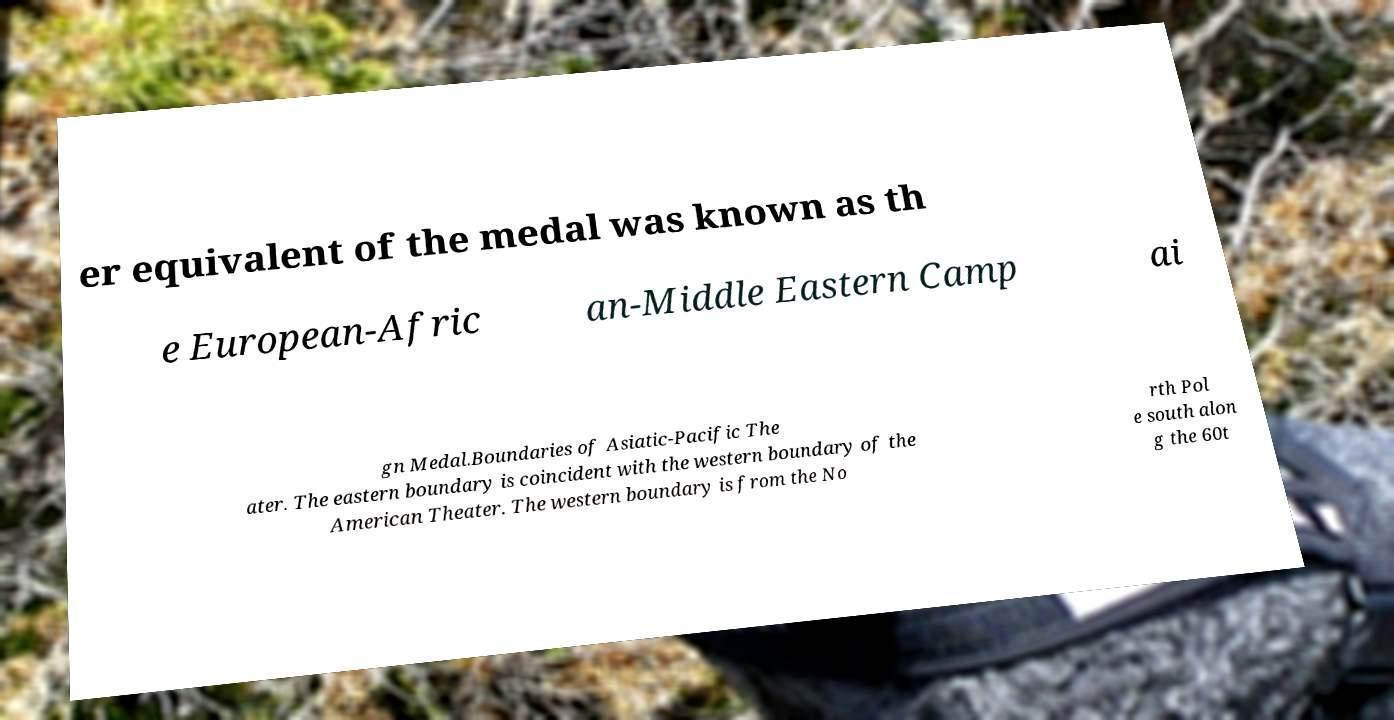Can you accurately transcribe the text from the provided image for me? er equivalent of the medal was known as th e European-Afric an-Middle Eastern Camp ai gn Medal.Boundaries of Asiatic-Pacific The ater. The eastern boundary is coincident with the western boundary of the American Theater. The western boundary is from the No rth Pol e south alon g the 60t 